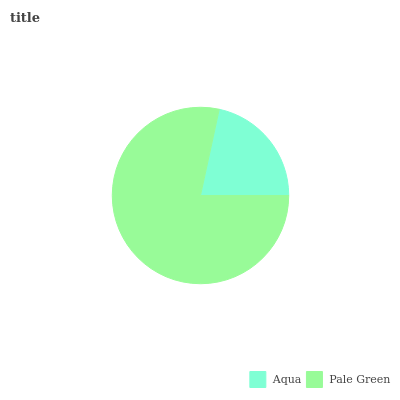Is Aqua the minimum?
Answer yes or no. Yes. Is Pale Green the maximum?
Answer yes or no. Yes. Is Pale Green the minimum?
Answer yes or no. No. Is Pale Green greater than Aqua?
Answer yes or no. Yes. Is Aqua less than Pale Green?
Answer yes or no. Yes. Is Aqua greater than Pale Green?
Answer yes or no. No. Is Pale Green less than Aqua?
Answer yes or no. No. Is Pale Green the high median?
Answer yes or no. Yes. Is Aqua the low median?
Answer yes or no. Yes. Is Aqua the high median?
Answer yes or no. No. Is Pale Green the low median?
Answer yes or no. No. 